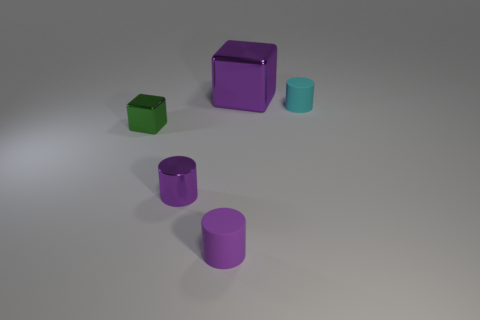Add 4 tiny cyan objects. How many objects exist? 9 Subtract all cylinders. How many objects are left? 2 Subtract all big metal things. Subtract all green things. How many objects are left? 3 Add 2 tiny purple cylinders. How many tiny purple cylinders are left? 4 Add 1 small yellow matte things. How many small yellow matte things exist? 1 Subtract 0 purple balls. How many objects are left? 5 